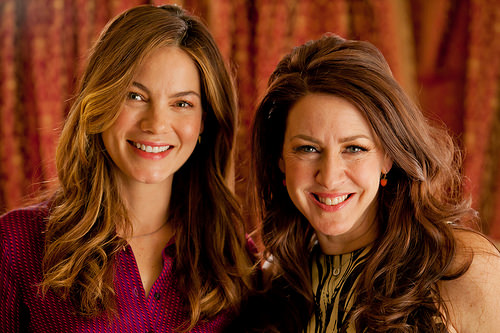<image>
Is the girl in front of the girl? No. The girl is not in front of the girl. The spatial positioning shows a different relationship between these objects. 